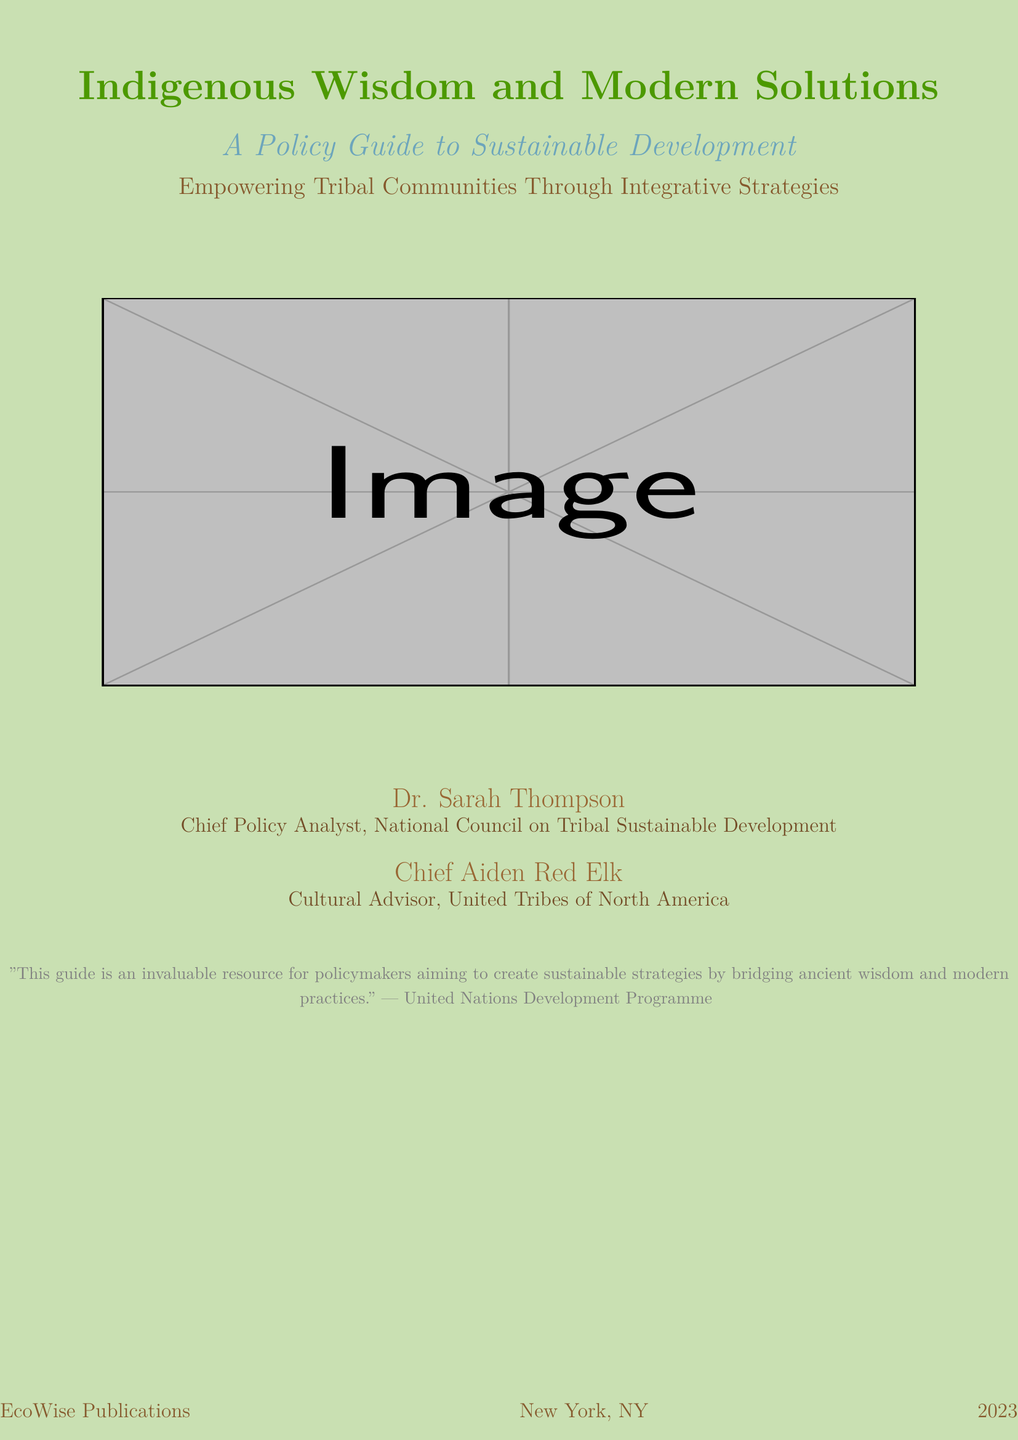What is the title of the book? The title is prominently displayed at the top of the cover.
Answer: Indigenous Wisdom and Modern Solutions Who are the authors listed on the cover? The cover features the names of the authors at the bottom.
Answer: Dr. Sarah Thompson and Chief Aiden Red Elk What year was the book published? The publication year is found in the lower section of the cover.
Answer: 2023 What is the main theme of the book? The theme is indicated by the subtitle on the cover.
Answer: A Policy Guide to Sustainable Development Which organization provided the quote on the cover? The source of the quote is mentioned at the bottom of the cover.
Answer: United Nations Development Programme What color is used for the background of the cover? The background color is specified in the design description.
Answer: Earthy green What type of publication is this document classified as? The nature of the document is implied from its structure and design.
Answer: Book cover What department is Dr. Sarah Thompson associated with? The affiliation of Dr. Sarah Thompson is noted beneath her name.
Answer: National Council on Tribal Sustainable Development What type of advisor is Chief Aiden Red Elk? Chief Aiden Red Elk’s role is specified under his name on the cover.
Answer: Cultural Advisor 